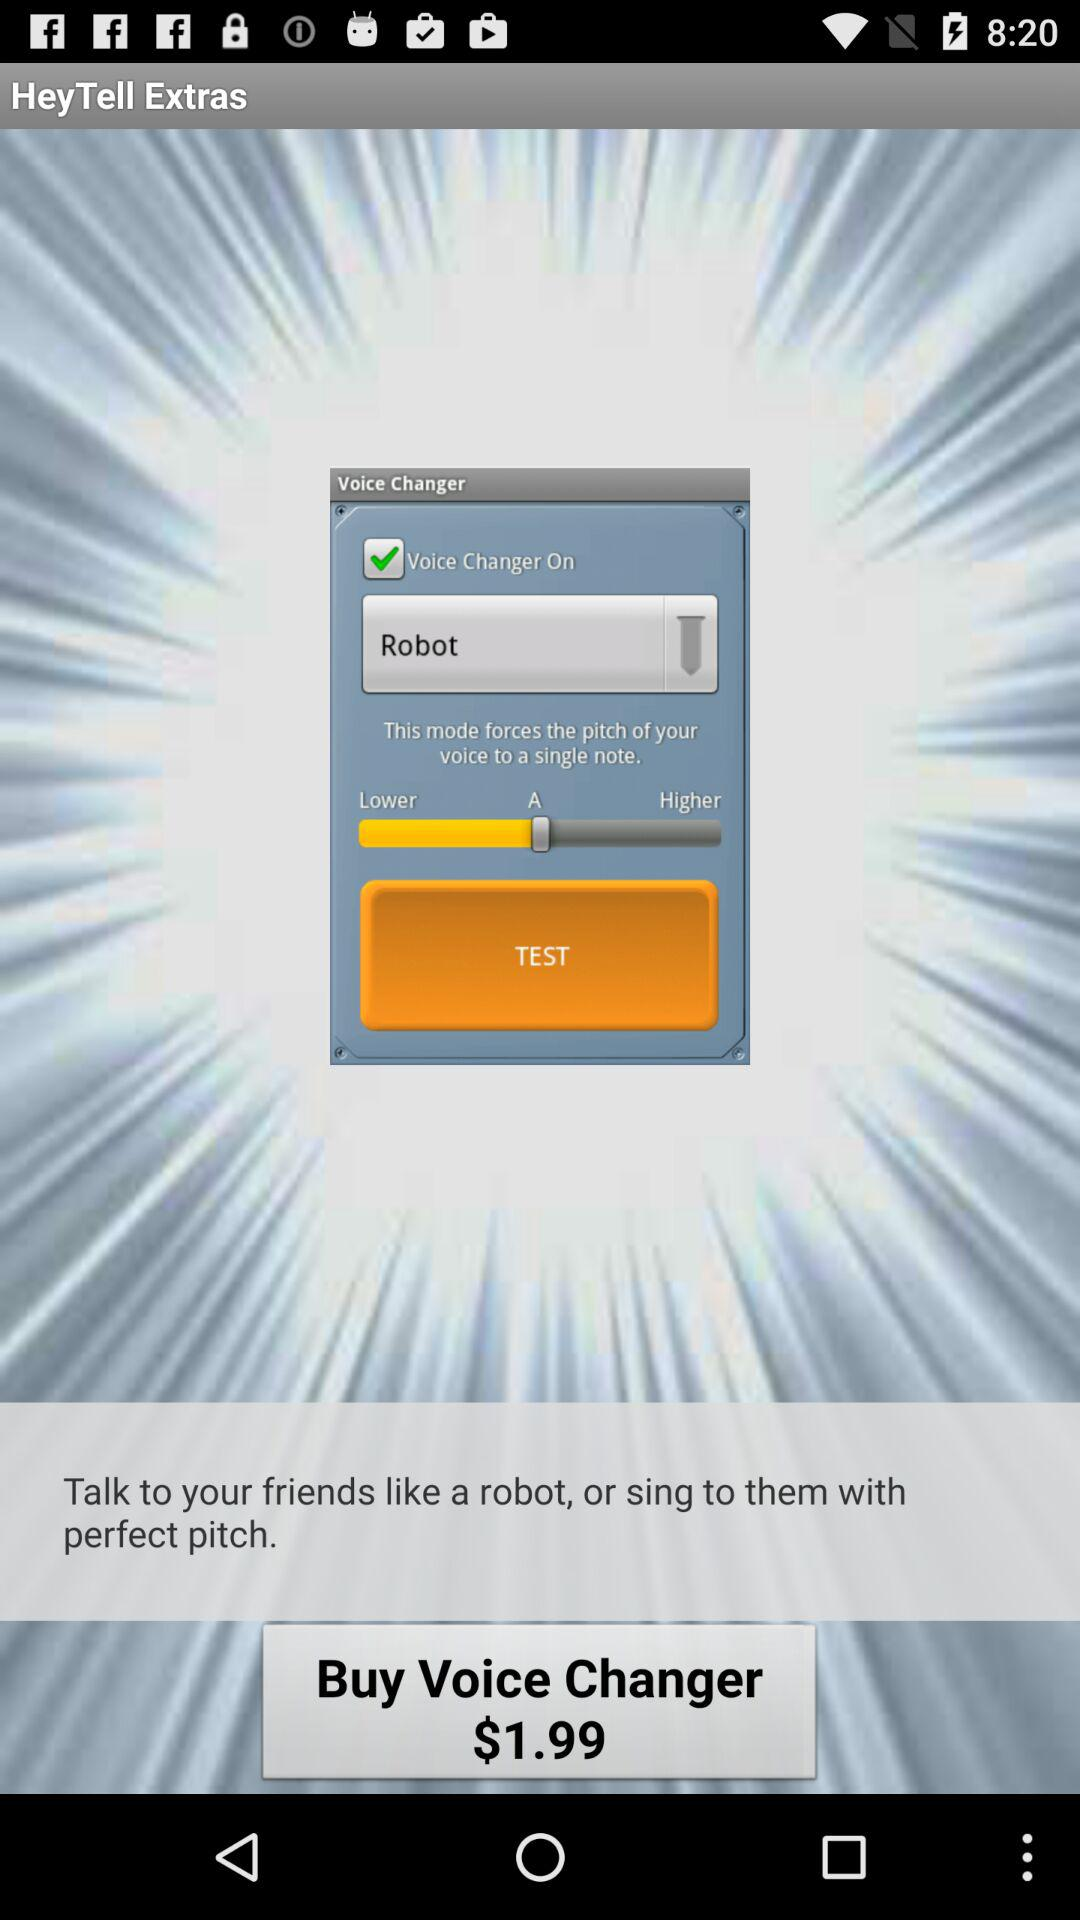How much does the "Voice Changer" application cost? The cost of the application is $1.99. 